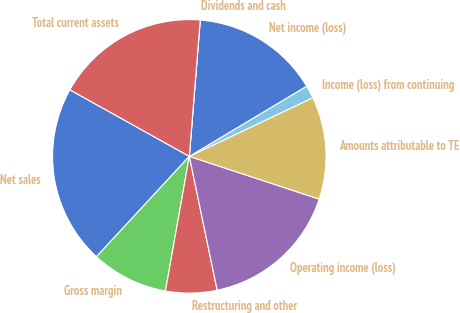<chart> <loc_0><loc_0><loc_500><loc_500><pie_chart><fcel>Net sales<fcel>Gross margin<fcel>Restructuring and other<fcel>Operating income (loss)<fcel>Amounts attributable to TE<fcel>Income (loss) from continuing<fcel>Net income (loss)<fcel>Dividends and cash<fcel>Total current assets<nl><fcel>21.21%<fcel>9.09%<fcel>6.06%<fcel>16.67%<fcel>12.12%<fcel>1.52%<fcel>15.15%<fcel>0.0%<fcel>18.18%<nl></chart> 